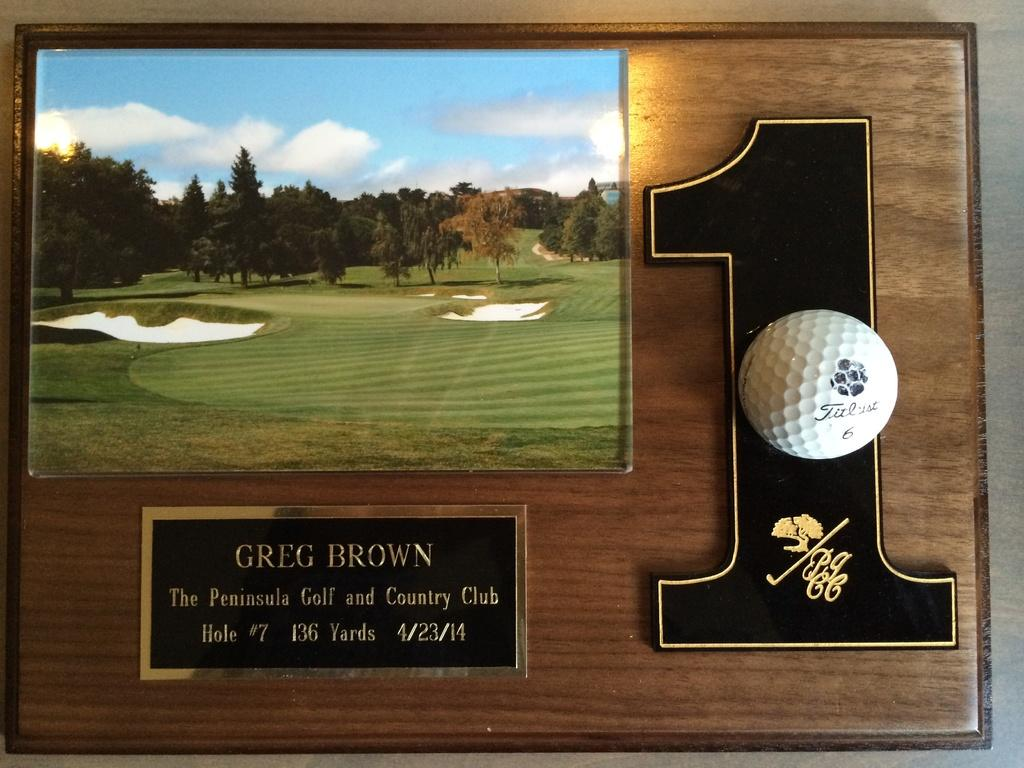<image>
Relay a brief, clear account of the picture shown. A picture of a golf course hangs above a plague commemorating Greg Brown. 